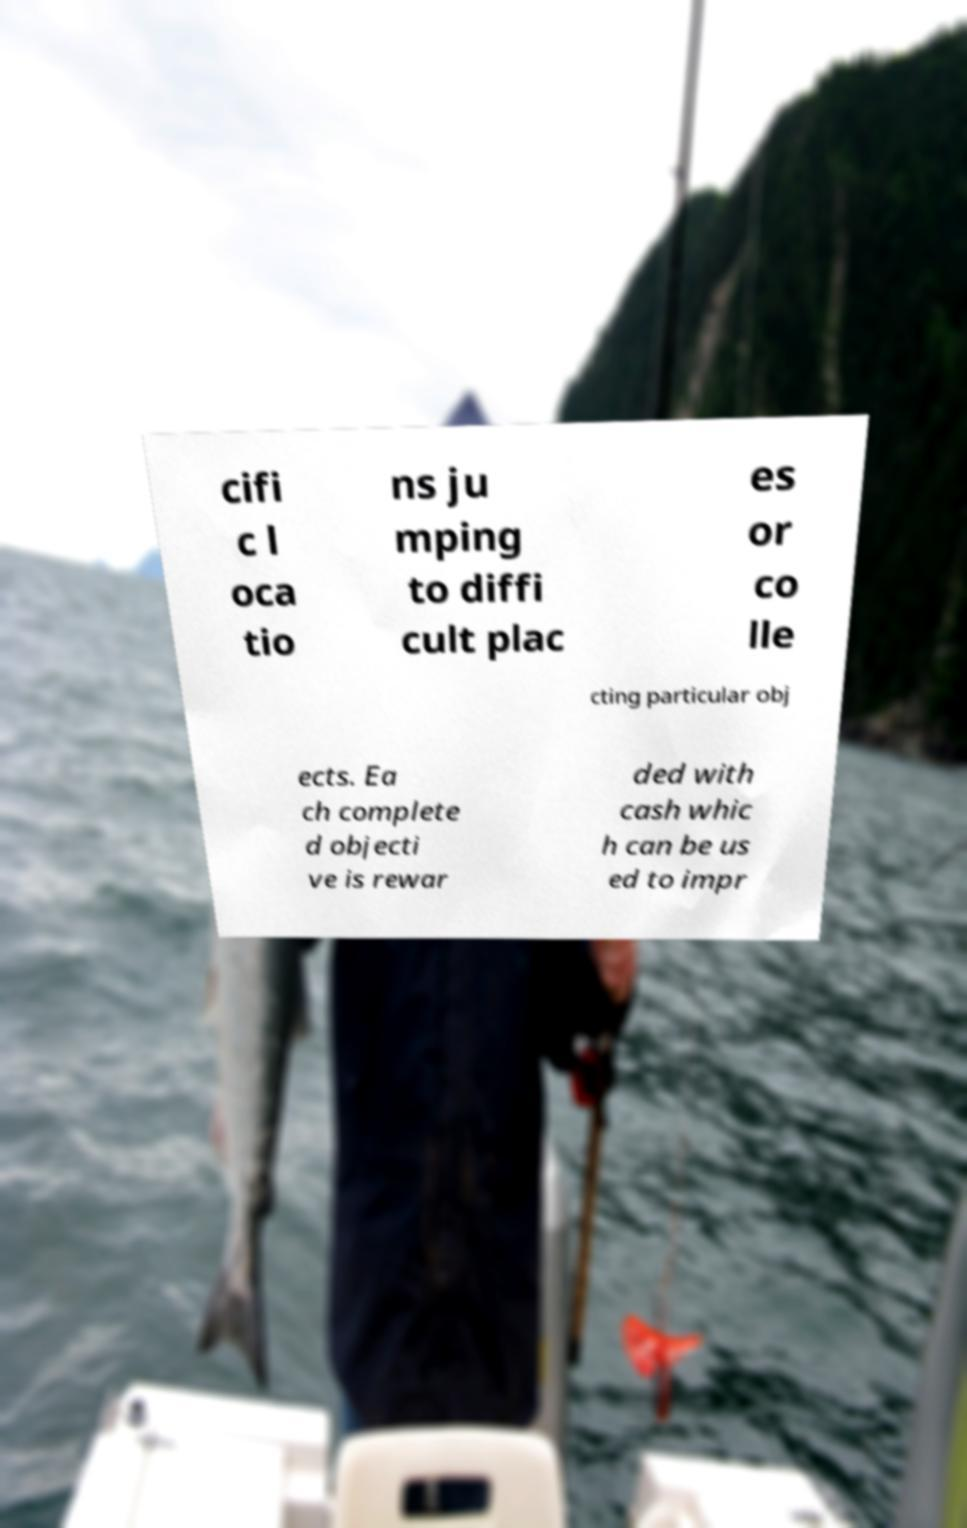Please identify and transcribe the text found in this image. cifi c l oca tio ns ju mping to diffi cult plac es or co lle cting particular obj ects. Ea ch complete d objecti ve is rewar ded with cash whic h can be us ed to impr 